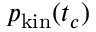Convert formula to latex. <formula><loc_0><loc_0><loc_500><loc_500>p _ { k i n } ( t _ { c } )</formula> 